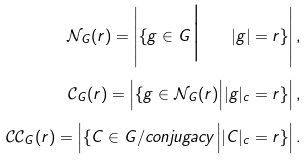Convert formula to latex. <formula><loc_0><loc_0><loc_500><loc_500>\mathcal { N } _ { G } ( r ) = \left | \{ g \in G \Big | \quad | g | = r \} \right | , \\ \mathcal { C } _ { G } ( r ) = \left | \{ g \in \mathcal { N } _ { G } ( r ) \Big | | g | _ { c } = r \} \right | , \\ \mathcal { C } \mathcal { C } _ { G } ( r ) = \left | \{ C \in G / c o n j u g a c y \Big | | C | _ { c } = r \} \right | .</formula> 